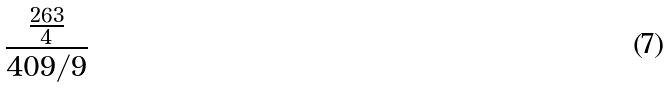<formula> <loc_0><loc_0><loc_500><loc_500>\frac { \frac { 2 6 3 } { 4 } } { 4 0 9 / 9 }</formula> 